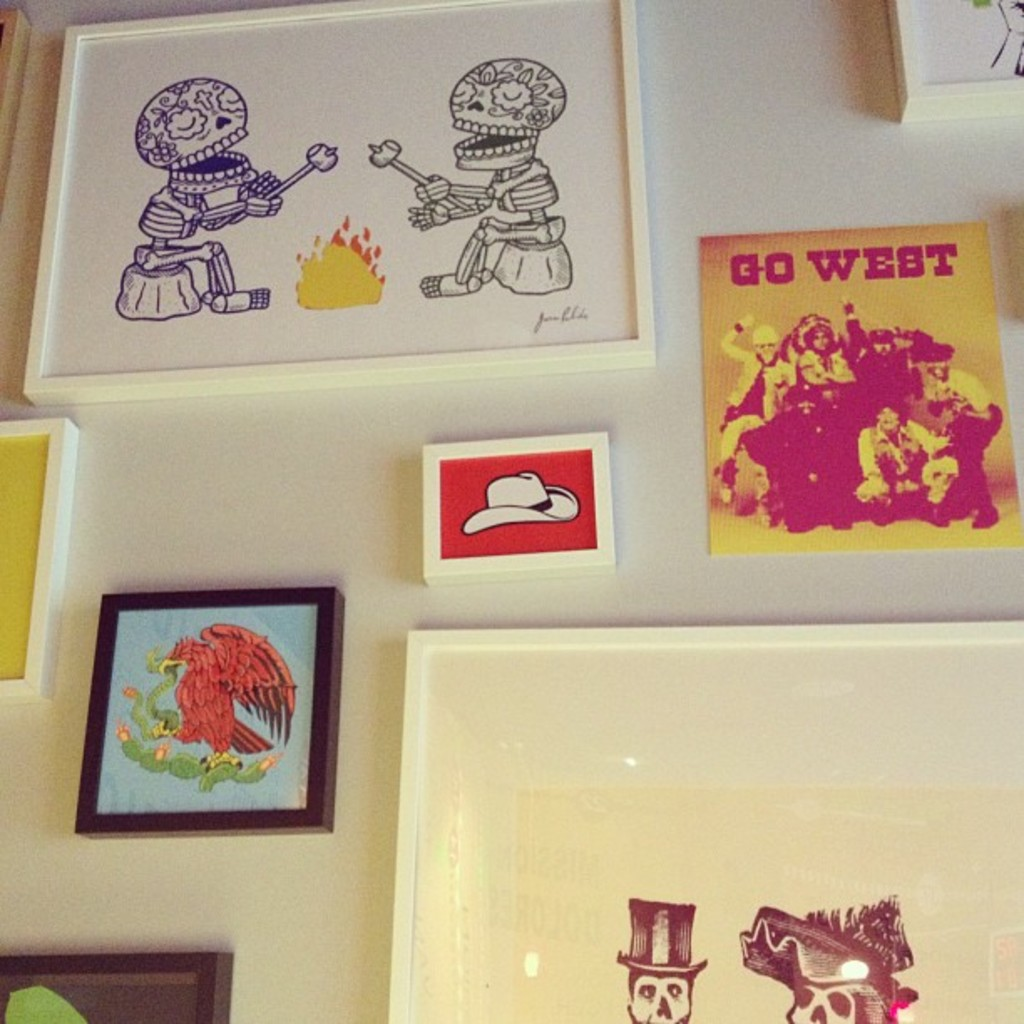Can you describe the artistic style used in the pieces shown in the image? The artworks embody a mix of pop art and modern graphic illustrations, utilizing vibrant colors and bold outlines. The pieces display a playful yet poignant portrayal of figures and themes, like the cartoonish skeletons and the vivid phoenix, which add a layer of depth to the otherwise light-hearted style. 